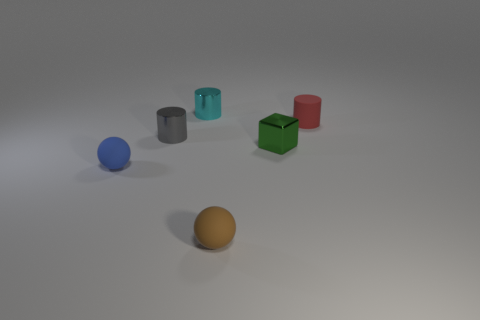Is the number of small metal objects greater than the number of tiny blue blocks? While assessing the image, it appears that there are two small metal-like cylinders, but only one blue spherical object that could be interpreted as a block due to its shape and size. Therefore, without more details to clarify what counts as 'tiny' and 'small', the conclusion is that the number of metal objects equals the number of blue objects that could be considered as blocks. 